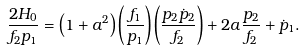<formula> <loc_0><loc_0><loc_500><loc_500>\frac { 2 H _ { 0 } } { f _ { 2 } p _ { 1 } } = \left ( 1 + a ^ { 2 } \right ) \left ( \frac { f _ { 1 } } { p _ { 1 } } \right ) \left ( \frac { p _ { 2 } \dot { p } _ { 2 } } { f _ { 2 } } \right ) + 2 a \frac { p _ { 2 } } { f _ { 2 } } + \dot { p } _ { 1 } .</formula> 